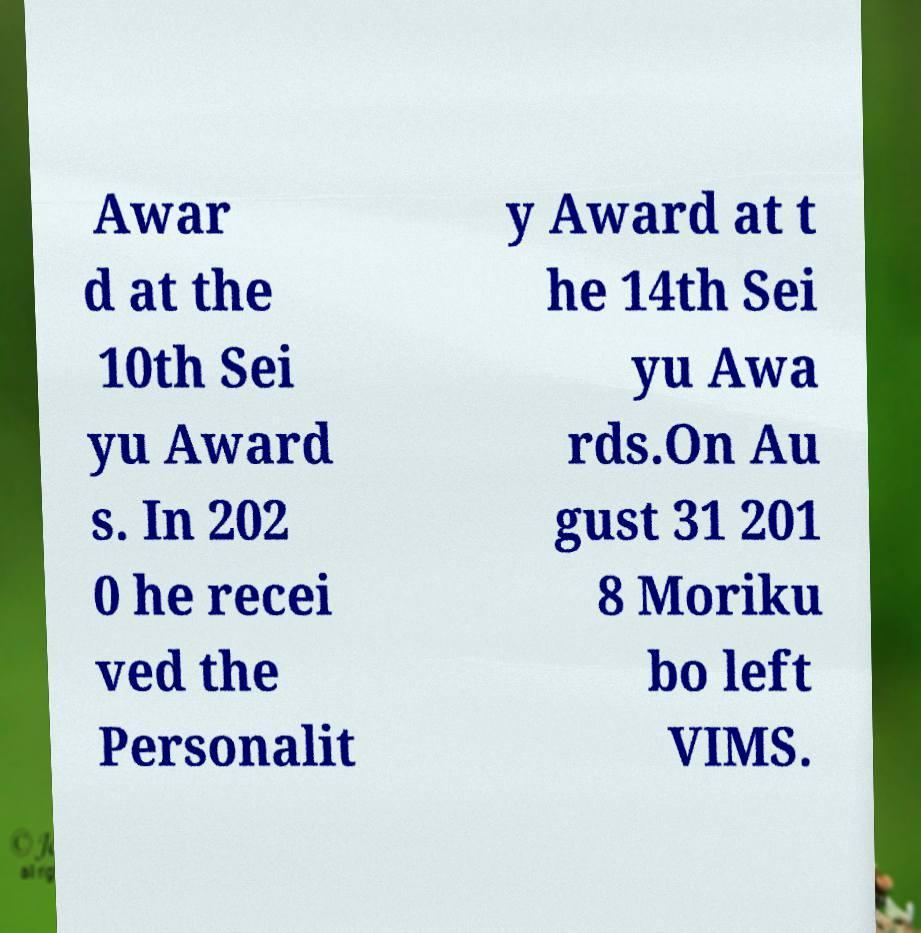I need the written content from this picture converted into text. Can you do that? Awar d at the 10th Sei yu Award s. In 202 0 he recei ved the Personalit y Award at t he 14th Sei yu Awa rds.On Au gust 31 201 8 Moriku bo left VIMS. 